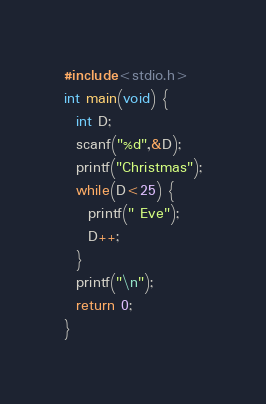Convert code to text. <code><loc_0><loc_0><loc_500><loc_500><_C_>#include<stdio.h>
int main(void) {
  int D;
  scanf("%d",&D);
  printf("Christmas");
  while(D<25) {
    printf(" Eve");
    D++;
  }
  printf("\n");
  return 0;
}</code> 